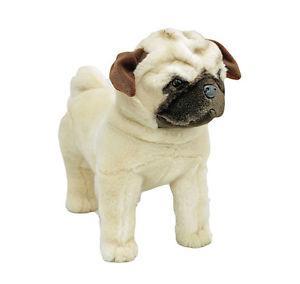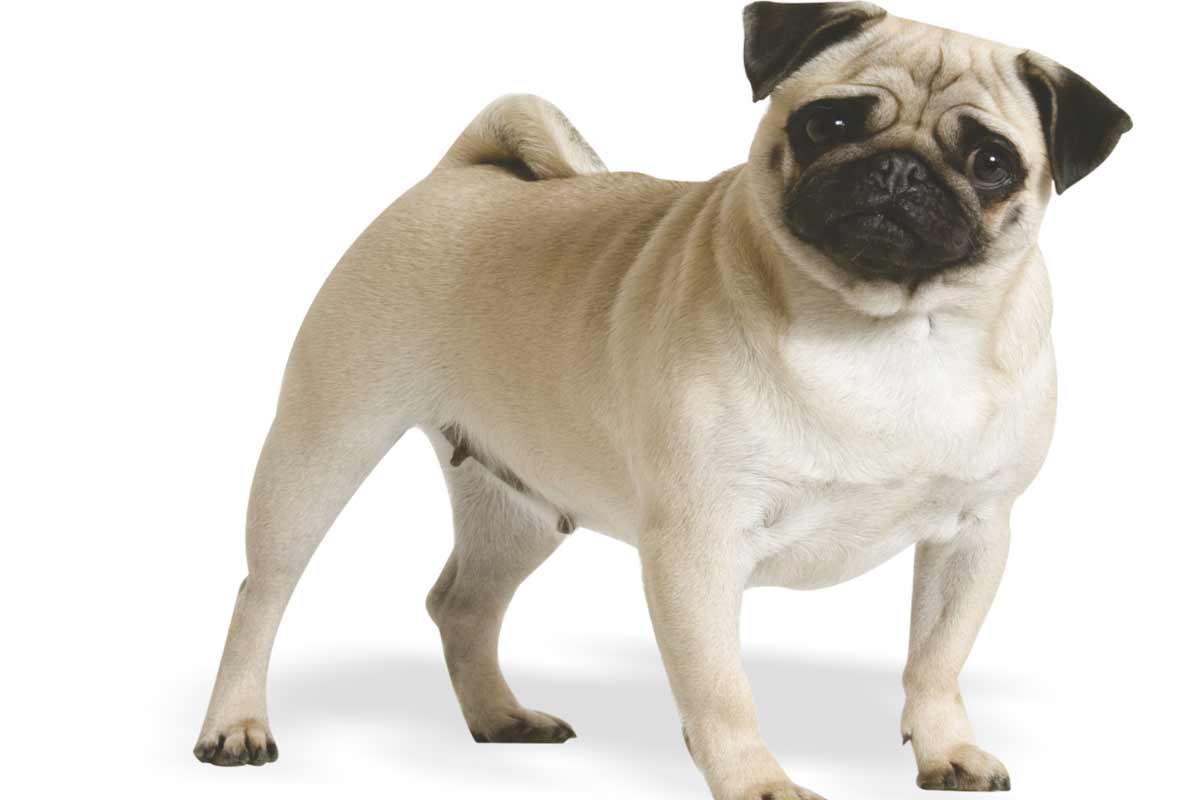The first image is the image on the left, the second image is the image on the right. Assess this claim about the two images: "In one of the images, a dog is sitting down". Correct or not? Answer yes or no. No. 